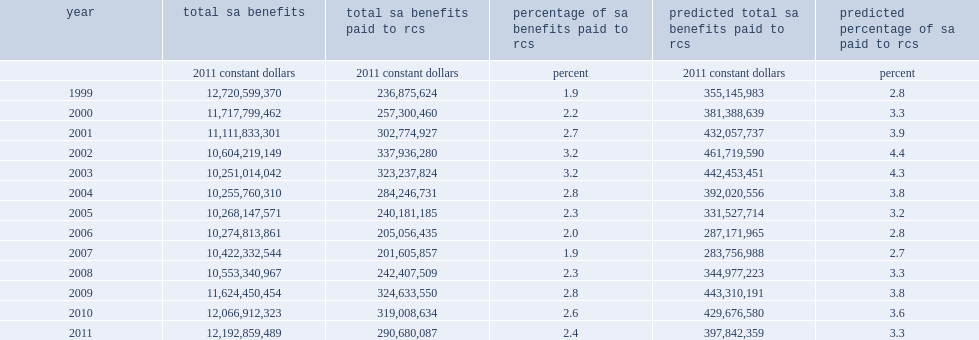List all years when refugee claimant families receive less than 5% of total social assistance payments made in canada. 1999.0 2000.0 2001.0 2002.0 2003.0 2004.0 2006.0 2005.0 2007.0 2008.0 2009.0 2010.0 2011.0. Of these totals, what was the minimum annual amount paid to refugee claimants depending on the year? 201605857. Of these totals, what was the maximum annual amount paid to refugee claimants depending on the year? 337936280. Assuming that social assistance receipt patterns were similar for linked and unlinked refugee claimants, what was the minimum annual amounts paid to refugee claimants? 283756988. Assuming that social assistance receipt patterns were similar for linked and unlinked refugee claimants, what was the maximum annual amounts paid to refugee claimants? 461719590. Assuming that social assistance receipt patterns were similar for linked and unlinked refugee claimants, what was the minimum percentage of the annual amount paid to refugee claimants of total social assistance expenditures? 2.7. Assuming that social assistance receipt patterns were similar for linked and unlinked refugee claimants, what was the maximum percentage of the annual amount paid to refugee claimants of total social assistance expenditures? 4.4. 